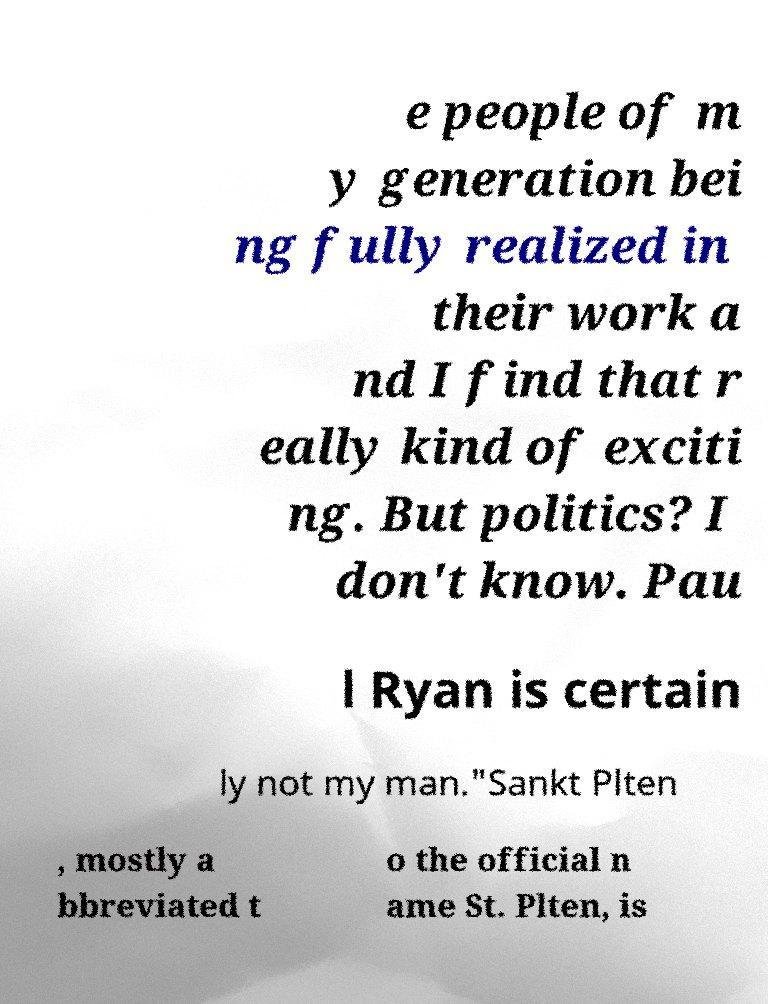Could you assist in decoding the text presented in this image and type it out clearly? e people of m y generation bei ng fully realized in their work a nd I find that r eally kind of exciti ng. But politics? I don't know. Pau l Ryan is certain ly not my man."Sankt Plten , mostly a bbreviated t o the official n ame St. Plten, is 